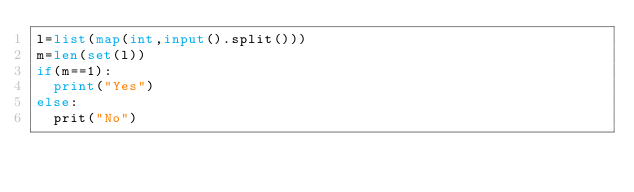Convert code to text. <code><loc_0><loc_0><loc_500><loc_500><_Python_>l=list(map(int,input().split()))
m=len(set(l))
if(m==1):
  print("Yes")
else:
  prit("No")</code> 